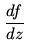Convert formula to latex. <formula><loc_0><loc_0><loc_500><loc_500>\frac { d f } { d z }</formula> 